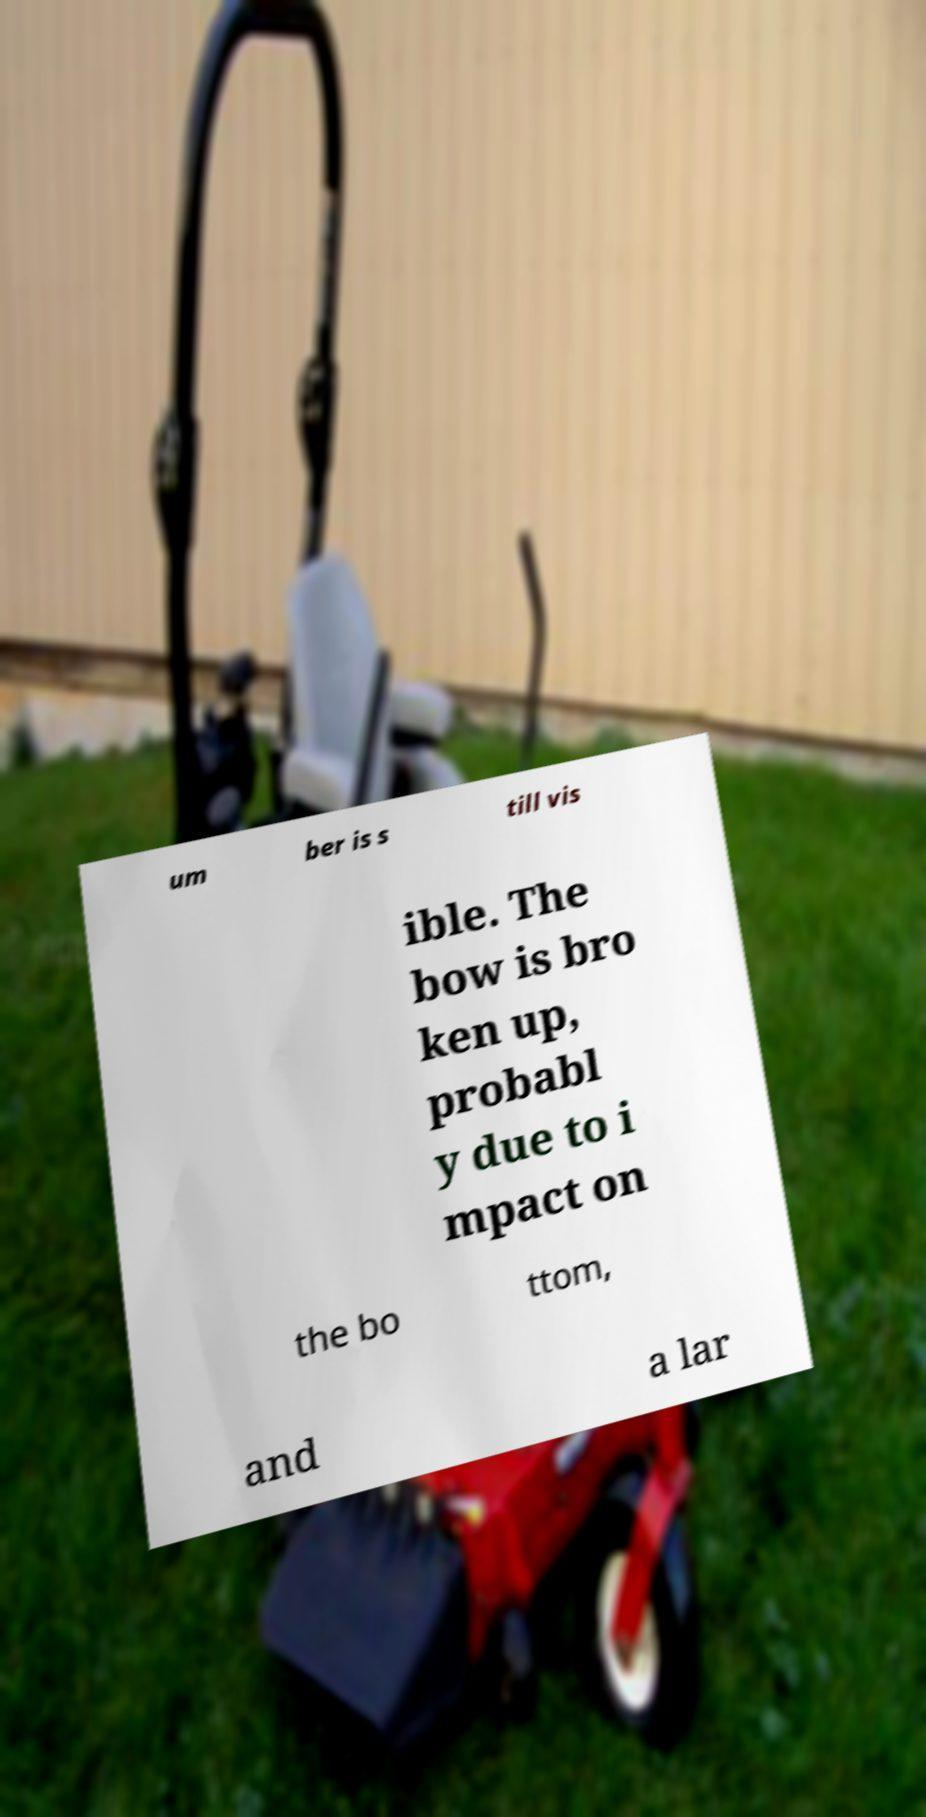Could you extract and type out the text from this image? um ber is s till vis ible. The bow is bro ken up, probabl y due to i mpact on the bo ttom, and a lar 